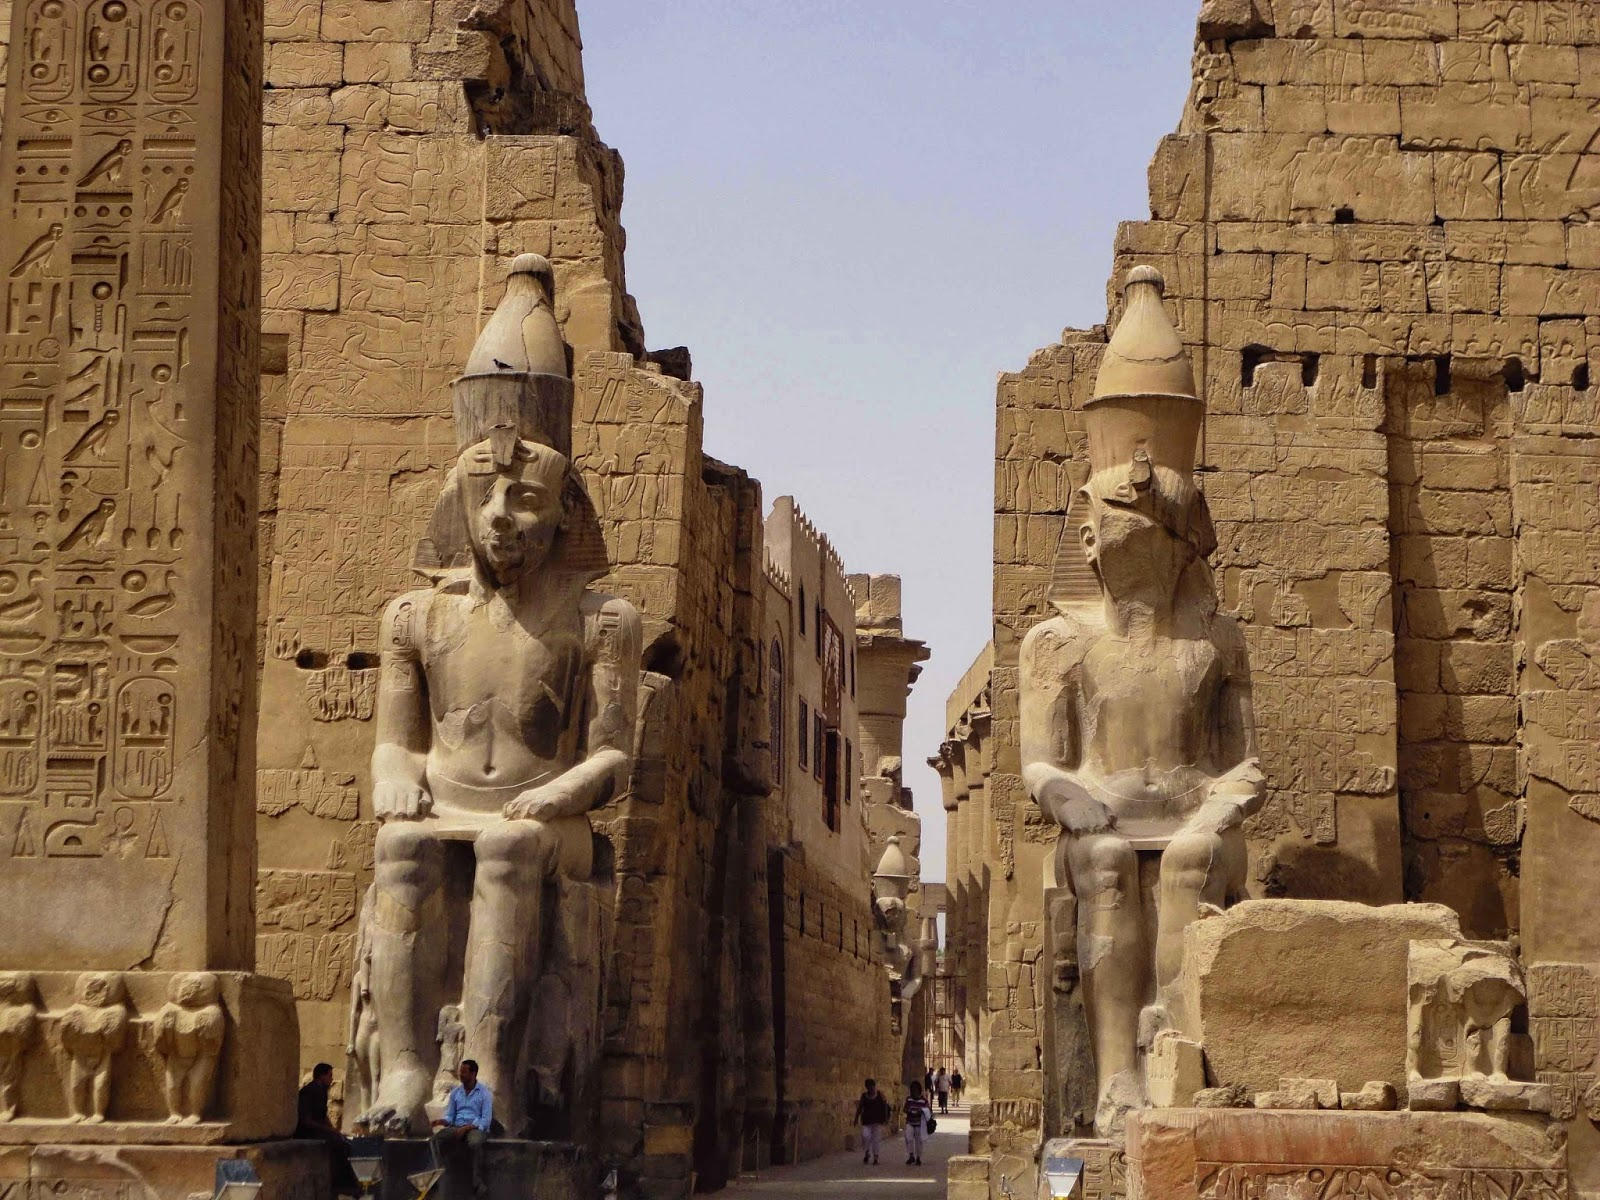What do you think is going on in this snapshot? The image portrays the magnificent Luxor Temple in Egypt, a striking example of ancient Egyptian architecture. The view is from the entrance, drawing the viewer into the historic heart of the temple. The central pathway is flanked by imposing stone statues of pharaohs, showcasing detailed craftsmanship. These statues, worn by centuries of exposure, stand as guardians, enhancing the temple's enigmatic atmosphere.

The walls on either side of the statues are richly inscribed with hieroglyphics, narrating stories from the past. The bright blue sky contrasts sharply with the sunlit, golden-colored stone, illuminating the grandeur of the structures. This image beautifully captures a moment at Luxor Temple, blending historical richness with natural beauty. 